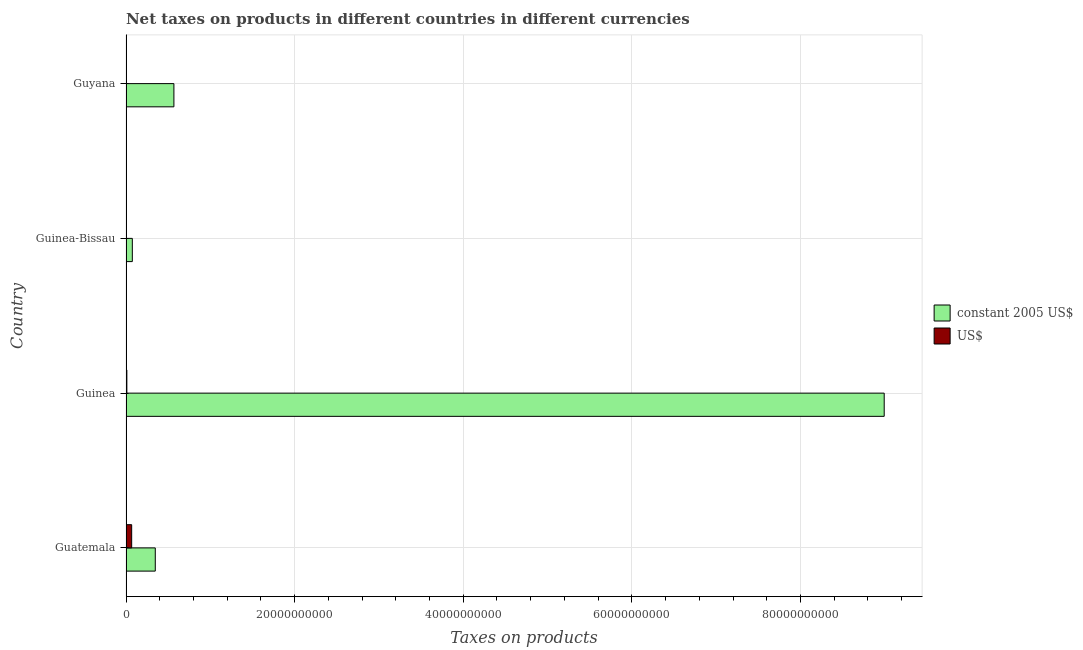Are the number of bars on each tick of the Y-axis equal?
Provide a short and direct response. Yes. How many bars are there on the 2nd tick from the top?
Offer a very short reply. 2. How many bars are there on the 2nd tick from the bottom?
Your answer should be very brief. 2. What is the label of the 4th group of bars from the top?
Your answer should be compact. Guatemala. In how many cases, is the number of bars for a given country not equal to the number of legend labels?
Offer a terse response. 0. What is the net taxes in us$ in Guinea-Bissau?
Make the answer very short. 7.02e+06. Across all countries, what is the maximum net taxes in constant 2005 us$?
Your answer should be compact. 8.99e+1. Across all countries, what is the minimum net taxes in constant 2005 us$?
Offer a very short reply. 7.49e+08. In which country was the net taxes in constant 2005 us$ maximum?
Provide a short and direct response. Guinea. In which country was the net taxes in constant 2005 us$ minimum?
Offer a terse response. Guinea-Bissau. What is the total net taxes in us$ in the graph?
Your answer should be very brief. 8.24e+08. What is the difference between the net taxes in constant 2005 us$ in Guatemala and that in Guinea-Bissau?
Provide a succinct answer. 2.72e+09. What is the difference between the net taxes in us$ in Guatemala and the net taxes in constant 2005 us$ in Guyana?
Make the answer very short. -5.01e+09. What is the average net taxes in constant 2005 us$ per country?
Make the answer very short. 2.50e+1. What is the difference between the net taxes in us$ and net taxes in constant 2005 us$ in Guinea?
Make the answer very short. -8.98e+1. What is the ratio of the net taxes in us$ in Guatemala to that in Guyana?
Provide a succinct answer. 14.79. Is the net taxes in constant 2005 us$ in Guatemala less than that in Guinea-Bissau?
Your answer should be compact. No. What is the difference between the highest and the second highest net taxes in constant 2005 us$?
Give a very brief answer. 8.42e+1. What is the difference between the highest and the lowest net taxes in us$?
Your answer should be compact. 6.64e+08. In how many countries, is the net taxes in constant 2005 us$ greater than the average net taxes in constant 2005 us$ taken over all countries?
Offer a very short reply. 1. What does the 2nd bar from the top in Guatemala represents?
Make the answer very short. Constant 2005 us$. What does the 2nd bar from the bottom in Guatemala represents?
Keep it short and to the point. US$. How many countries are there in the graph?
Provide a succinct answer. 4. What is the difference between two consecutive major ticks on the X-axis?
Keep it short and to the point. 2.00e+1. Does the graph contain any zero values?
Your answer should be compact. No. Does the graph contain grids?
Provide a short and direct response. Yes. How are the legend labels stacked?
Your answer should be compact. Vertical. What is the title of the graph?
Your response must be concise. Net taxes on products in different countries in different currencies. Does "Goods" appear as one of the legend labels in the graph?
Offer a terse response. No. What is the label or title of the X-axis?
Provide a succinct answer. Taxes on products. What is the label or title of the Y-axis?
Your answer should be compact. Country. What is the Taxes on products of constant 2005 US$ in Guatemala?
Your answer should be compact. 3.47e+09. What is the Taxes on products in US$ in Guatemala?
Your answer should be very brief. 6.71e+08. What is the Taxes on products in constant 2005 US$ in Guinea?
Your response must be concise. 8.99e+1. What is the Taxes on products of US$ in Guinea?
Offer a very short reply. 9.97e+07. What is the Taxes on products of constant 2005 US$ in Guinea-Bissau?
Ensure brevity in your answer.  7.49e+08. What is the Taxes on products of US$ in Guinea-Bissau?
Provide a succinct answer. 7.02e+06. What is the Taxes on products in constant 2005 US$ in Guyana?
Keep it short and to the point. 5.68e+09. What is the Taxes on products of US$ in Guyana?
Keep it short and to the point. 4.54e+07. Across all countries, what is the maximum Taxes on products in constant 2005 US$?
Provide a succinct answer. 8.99e+1. Across all countries, what is the maximum Taxes on products of US$?
Offer a very short reply. 6.71e+08. Across all countries, what is the minimum Taxes on products in constant 2005 US$?
Provide a short and direct response. 7.49e+08. Across all countries, what is the minimum Taxes on products in US$?
Ensure brevity in your answer.  7.02e+06. What is the total Taxes on products in constant 2005 US$ in the graph?
Your answer should be compact. 9.98e+1. What is the total Taxes on products of US$ in the graph?
Offer a very short reply. 8.24e+08. What is the difference between the Taxes on products of constant 2005 US$ in Guatemala and that in Guinea?
Provide a short and direct response. -8.65e+1. What is the difference between the Taxes on products of US$ in Guatemala and that in Guinea?
Give a very brief answer. 5.72e+08. What is the difference between the Taxes on products of constant 2005 US$ in Guatemala and that in Guinea-Bissau?
Provide a short and direct response. 2.72e+09. What is the difference between the Taxes on products of US$ in Guatemala and that in Guinea-Bissau?
Provide a short and direct response. 6.64e+08. What is the difference between the Taxes on products in constant 2005 US$ in Guatemala and that in Guyana?
Provide a succinct answer. -2.21e+09. What is the difference between the Taxes on products of US$ in Guatemala and that in Guyana?
Provide a succinct answer. 6.26e+08. What is the difference between the Taxes on products of constant 2005 US$ in Guinea and that in Guinea-Bissau?
Your answer should be very brief. 8.92e+1. What is the difference between the Taxes on products of US$ in Guinea and that in Guinea-Bissau?
Provide a succinct answer. 9.27e+07. What is the difference between the Taxes on products of constant 2005 US$ in Guinea and that in Guyana?
Provide a succinct answer. 8.42e+1. What is the difference between the Taxes on products of US$ in Guinea and that in Guyana?
Your answer should be very brief. 5.43e+07. What is the difference between the Taxes on products in constant 2005 US$ in Guinea-Bissau and that in Guyana?
Your response must be concise. -4.93e+09. What is the difference between the Taxes on products of US$ in Guinea-Bissau and that in Guyana?
Your response must be concise. -3.84e+07. What is the difference between the Taxes on products in constant 2005 US$ in Guatemala and the Taxes on products in US$ in Guinea?
Make the answer very short. 3.37e+09. What is the difference between the Taxes on products of constant 2005 US$ in Guatemala and the Taxes on products of US$ in Guinea-Bissau?
Ensure brevity in your answer.  3.46e+09. What is the difference between the Taxes on products in constant 2005 US$ in Guatemala and the Taxes on products in US$ in Guyana?
Your answer should be very brief. 3.43e+09. What is the difference between the Taxes on products in constant 2005 US$ in Guinea and the Taxes on products in US$ in Guinea-Bissau?
Give a very brief answer. 8.99e+1. What is the difference between the Taxes on products of constant 2005 US$ in Guinea and the Taxes on products of US$ in Guyana?
Ensure brevity in your answer.  8.99e+1. What is the difference between the Taxes on products in constant 2005 US$ in Guinea-Bissau and the Taxes on products in US$ in Guyana?
Your answer should be compact. 7.04e+08. What is the average Taxes on products of constant 2005 US$ per country?
Give a very brief answer. 2.50e+1. What is the average Taxes on products of US$ per country?
Your response must be concise. 2.06e+08. What is the difference between the Taxes on products in constant 2005 US$ and Taxes on products in US$ in Guatemala?
Provide a succinct answer. 2.80e+09. What is the difference between the Taxes on products of constant 2005 US$ and Taxes on products of US$ in Guinea?
Your answer should be very brief. 8.98e+1. What is the difference between the Taxes on products of constant 2005 US$ and Taxes on products of US$ in Guinea-Bissau?
Keep it short and to the point. 7.42e+08. What is the difference between the Taxes on products in constant 2005 US$ and Taxes on products in US$ in Guyana?
Your answer should be very brief. 5.64e+09. What is the ratio of the Taxes on products in constant 2005 US$ in Guatemala to that in Guinea?
Provide a short and direct response. 0.04. What is the ratio of the Taxes on products of US$ in Guatemala to that in Guinea?
Provide a short and direct response. 6.74. What is the ratio of the Taxes on products of constant 2005 US$ in Guatemala to that in Guinea-Bissau?
Provide a succinct answer. 4.63. What is the ratio of the Taxes on products in US$ in Guatemala to that in Guinea-Bissau?
Keep it short and to the point. 95.61. What is the ratio of the Taxes on products of constant 2005 US$ in Guatemala to that in Guyana?
Your response must be concise. 0.61. What is the ratio of the Taxes on products of US$ in Guatemala to that in Guyana?
Provide a succinct answer. 14.79. What is the ratio of the Taxes on products of constant 2005 US$ in Guinea to that in Guinea-Bissau?
Your answer should be compact. 120.03. What is the ratio of the Taxes on products of US$ in Guinea to that in Guinea-Bissau?
Make the answer very short. 14.2. What is the ratio of the Taxes on products of constant 2005 US$ in Guinea to that in Guyana?
Make the answer very short. 15.83. What is the ratio of the Taxes on products in US$ in Guinea to that in Guyana?
Your answer should be compact. 2.2. What is the ratio of the Taxes on products in constant 2005 US$ in Guinea-Bissau to that in Guyana?
Keep it short and to the point. 0.13. What is the ratio of the Taxes on products in US$ in Guinea-Bissau to that in Guyana?
Provide a succinct answer. 0.15. What is the difference between the highest and the second highest Taxes on products in constant 2005 US$?
Your answer should be compact. 8.42e+1. What is the difference between the highest and the second highest Taxes on products of US$?
Offer a terse response. 5.72e+08. What is the difference between the highest and the lowest Taxes on products in constant 2005 US$?
Make the answer very short. 8.92e+1. What is the difference between the highest and the lowest Taxes on products in US$?
Provide a succinct answer. 6.64e+08. 